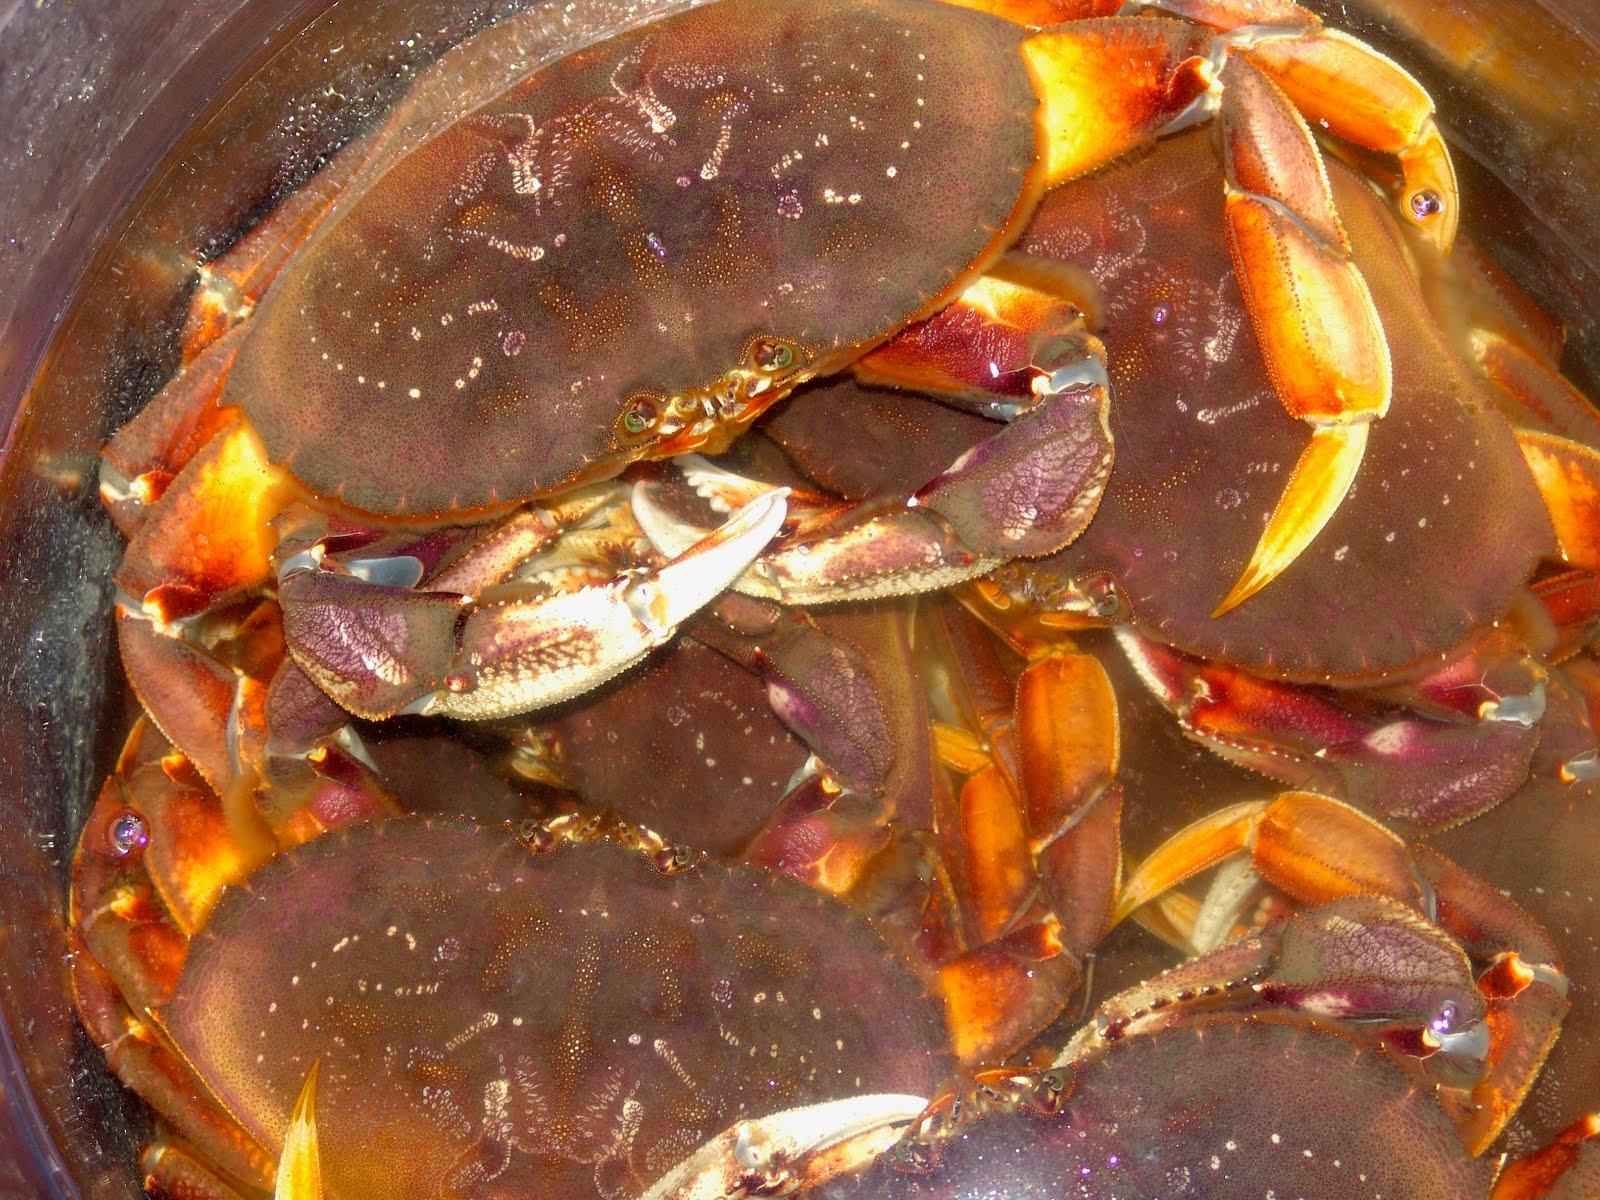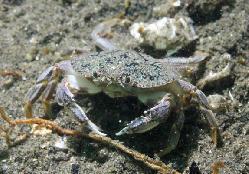The first image is the image on the left, the second image is the image on the right. Assess this claim about the two images: "The right image shows the top view of a crab with a grainy grayish shell, and the left image shows at least one crab with a pinker shell and yellow-tinted claws.". Correct or not? Answer yes or no. Yes. The first image is the image on the left, the second image is the image on the right. For the images displayed, is the sentence "in at least one image there is a single carb facing forward in water with coral in the background." factually correct? Answer yes or no. No. 